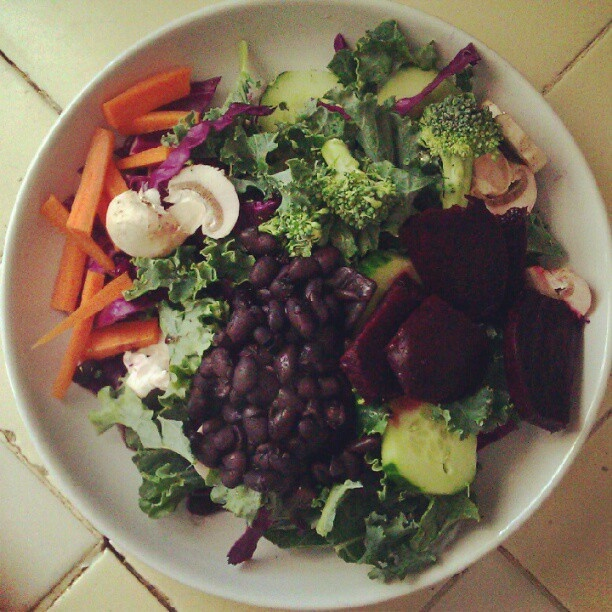Describe the objects in this image and their specific colors. I can see carrot in beige, brown, and tan tones, broccoli in beige, darkgreen, olive, gray, and black tones, broccoli in beige, olive, darkgreen, and black tones, and broccoli in beige, olive, darkgreen, and black tones in this image. 